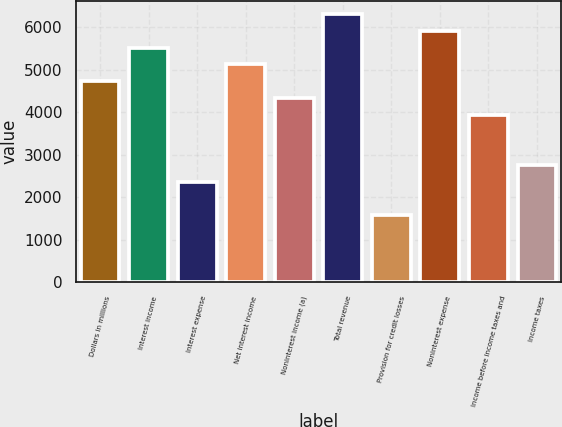Convert chart. <chart><loc_0><loc_0><loc_500><loc_500><bar_chart><fcel>Dollars in millions<fcel>Interest income<fcel>Interest expense<fcel>Net interest income<fcel>Noninterest income (a)<fcel>Total revenue<fcel>Provision for credit losses<fcel>Noninterest expense<fcel>Income before income taxes and<fcel>Income taxes<nl><fcel>4736.08<fcel>5525.12<fcel>2368.96<fcel>5130.6<fcel>4341.56<fcel>6314.16<fcel>1579.92<fcel>5919.64<fcel>3947.04<fcel>2763.48<nl></chart> 